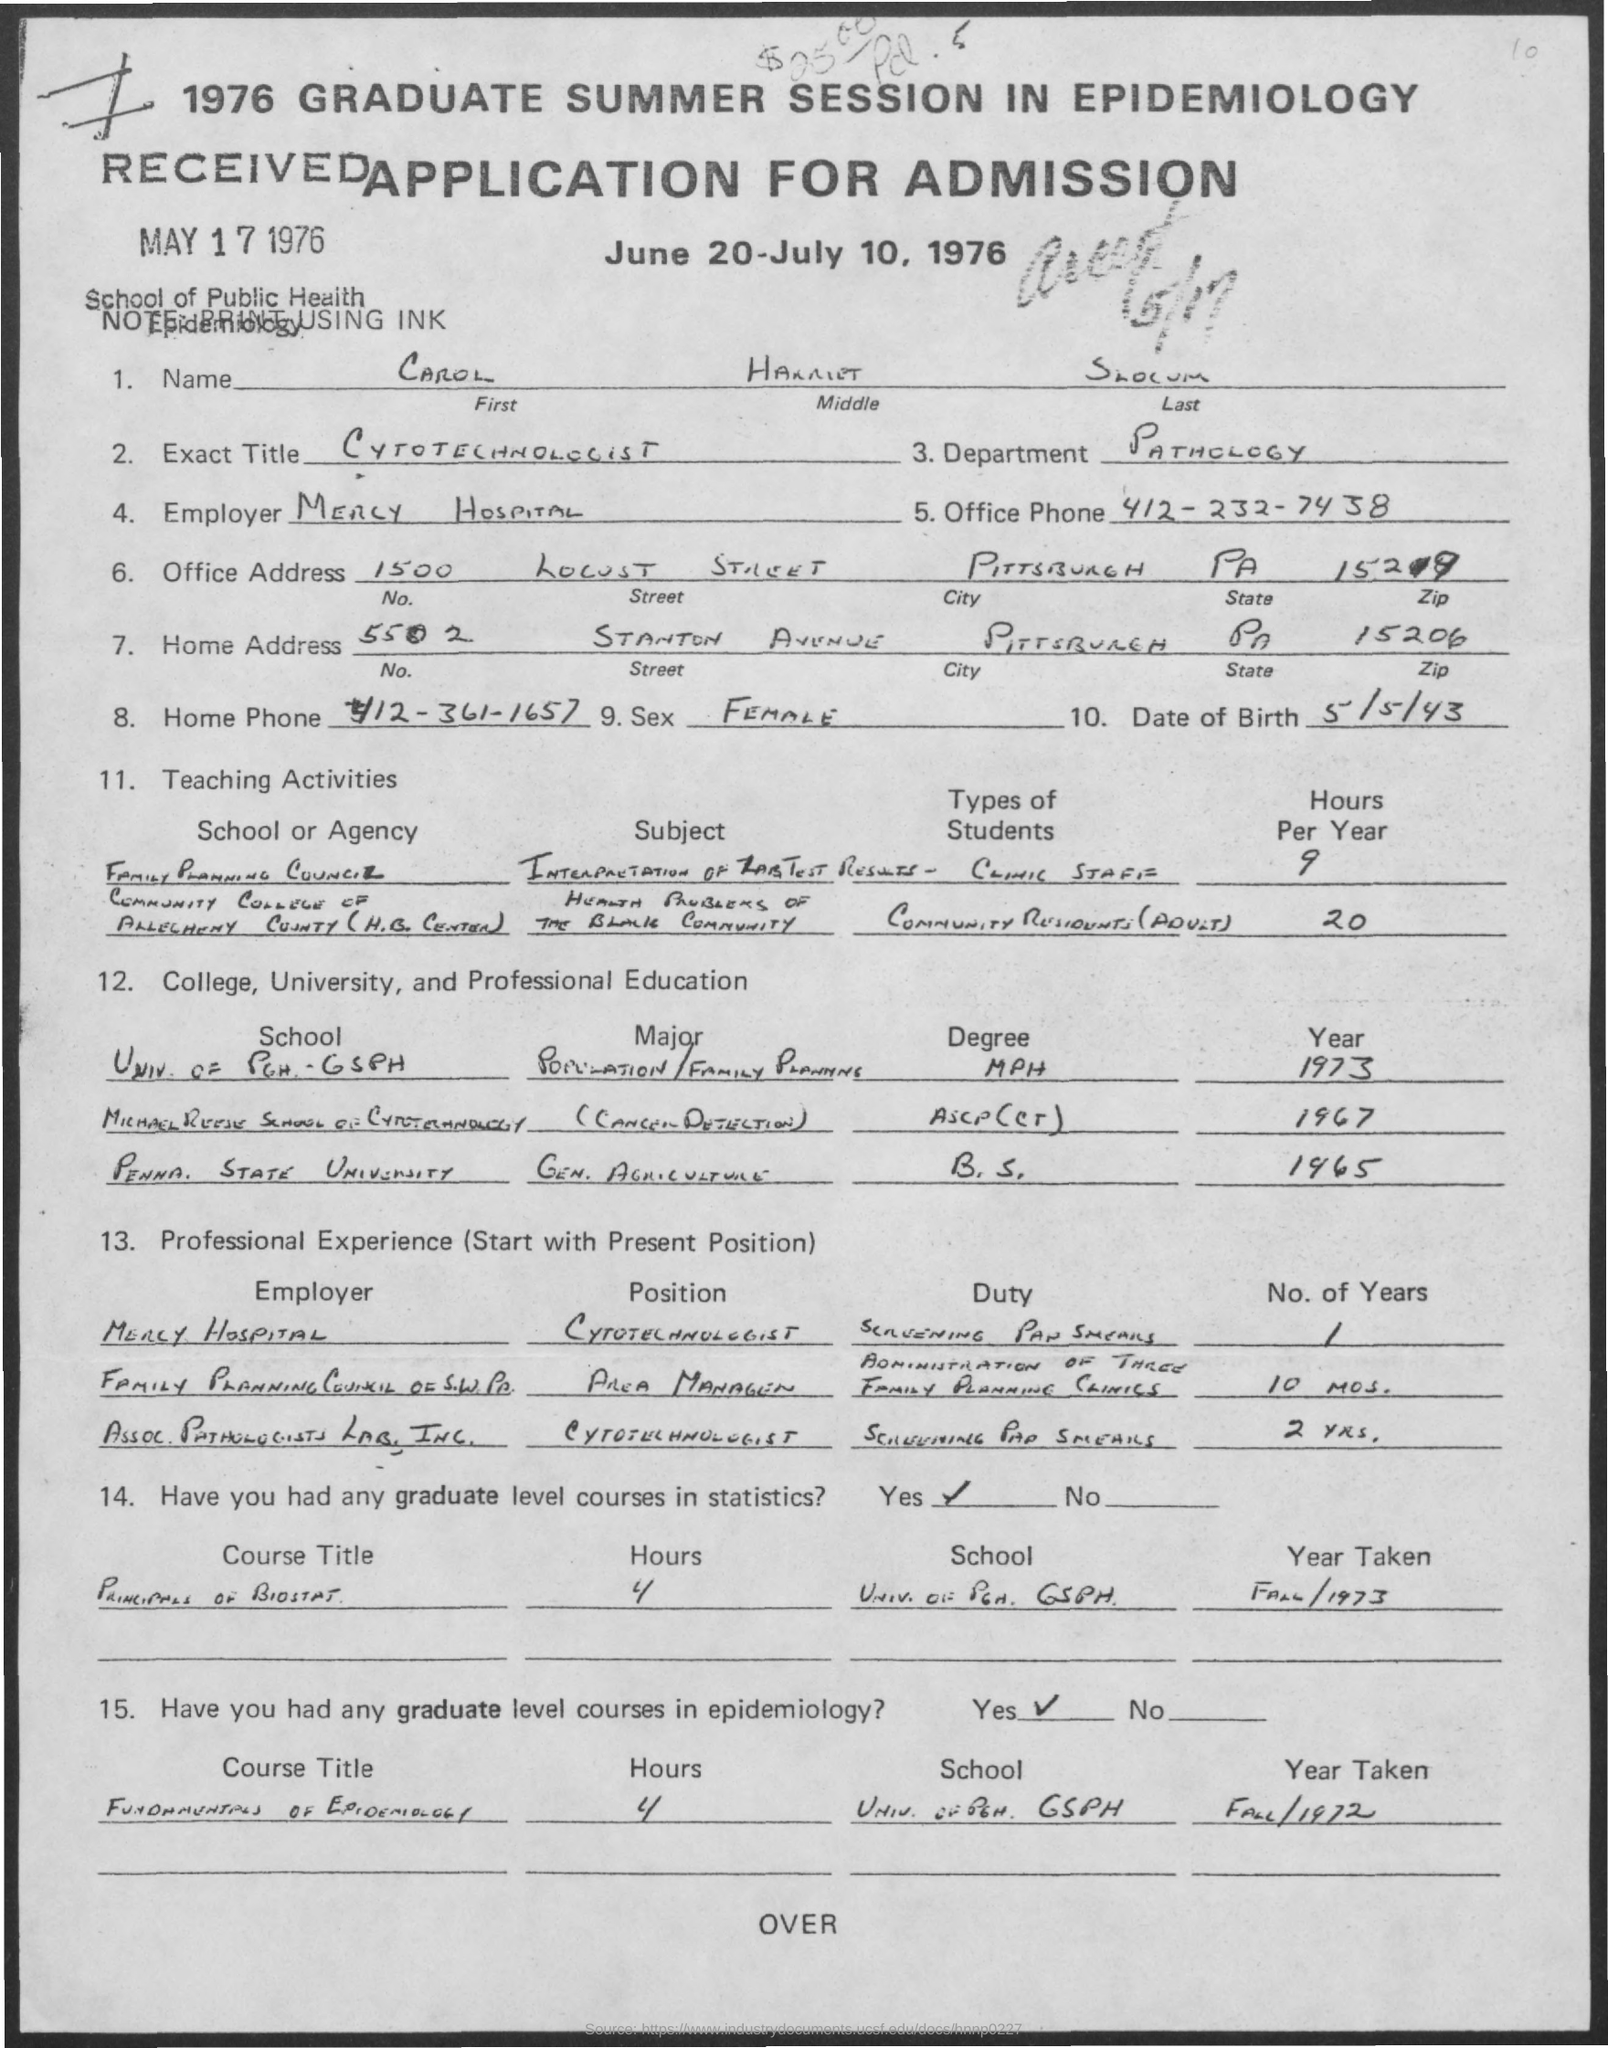When was the Application Received?
Offer a very short reply. May 17 1976. What is the First Name?
Keep it short and to the point. Carol. What is the Middle Name?
Your response must be concise. Harriet. What is the Department?
Provide a short and direct response. Pathology. What is the Office Phone?
Keep it short and to the point. 412-232-7438. Which is the City?
Make the answer very short. Pittsburgh. Which is the State?
Provide a succinct answer. PA. 